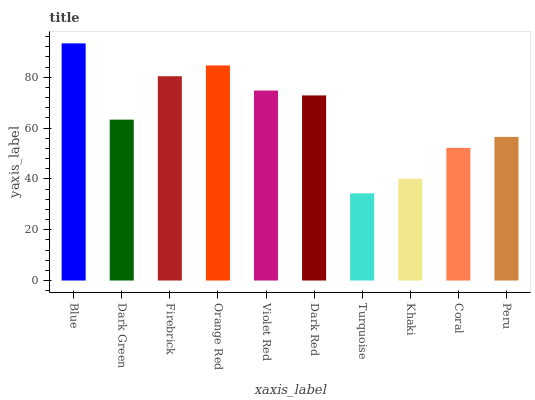Is Turquoise the minimum?
Answer yes or no. Yes. Is Blue the maximum?
Answer yes or no. Yes. Is Dark Green the minimum?
Answer yes or no. No. Is Dark Green the maximum?
Answer yes or no. No. Is Blue greater than Dark Green?
Answer yes or no. Yes. Is Dark Green less than Blue?
Answer yes or no. Yes. Is Dark Green greater than Blue?
Answer yes or no. No. Is Blue less than Dark Green?
Answer yes or no. No. Is Dark Red the high median?
Answer yes or no. Yes. Is Dark Green the low median?
Answer yes or no. Yes. Is Blue the high median?
Answer yes or no. No. Is Firebrick the low median?
Answer yes or no. No. 